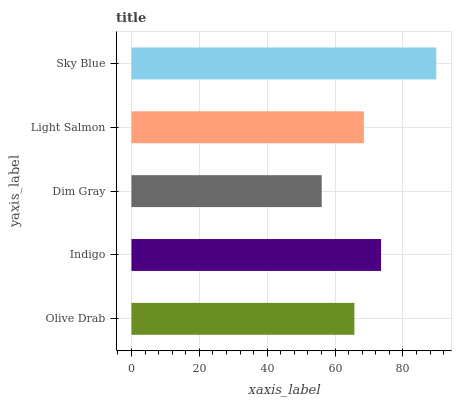Is Dim Gray the minimum?
Answer yes or no. Yes. Is Sky Blue the maximum?
Answer yes or no. Yes. Is Indigo the minimum?
Answer yes or no. No. Is Indigo the maximum?
Answer yes or no. No. Is Indigo greater than Olive Drab?
Answer yes or no. Yes. Is Olive Drab less than Indigo?
Answer yes or no. Yes. Is Olive Drab greater than Indigo?
Answer yes or no. No. Is Indigo less than Olive Drab?
Answer yes or no. No. Is Light Salmon the high median?
Answer yes or no. Yes. Is Light Salmon the low median?
Answer yes or no. Yes. Is Dim Gray the high median?
Answer yes or no. No. Is Dim Gray the low median?
Answer yes or no. No. 